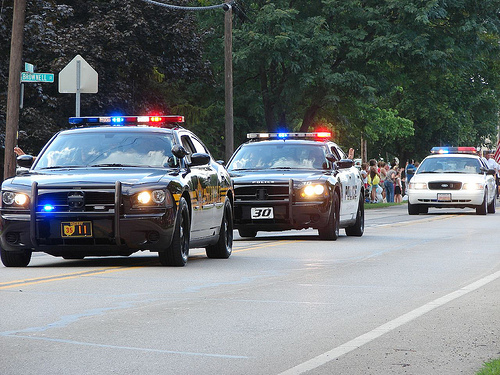<image>
Is the tree to the left of the car? No. The tree is not to the left of the car. From this viewpoint, they have a different horizontal relationship. Is there a crowd behind the car? Yes. From this viewpoint, the crowd is positioned behind the car, with the car partially or fully occluding the crowd. Where is the car in relation to the car? Is it next to the car? No. The car is not positioned next to the car. They are located in different areas of the scene. 